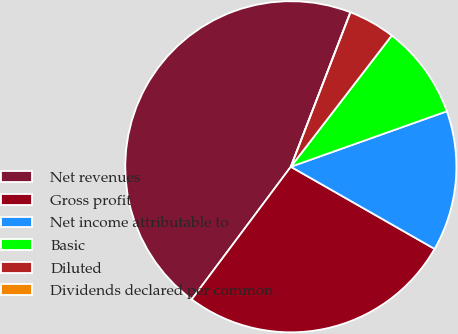Convert chart to OTSL. <chart><loc_0><loc_0><loc_500><loc_500><pie_chart><fcel>Net revenues<fcel>Gross profit<fcel>Net income attributable to<fcel>Basic<fcel>Diluted<fcel>Dividends declared per common<nl><fcel>45.65%<fcel>26.95%<fcel>13.7%<fcel>9.13%<fcel>4.57%<fcel>0.0%<nl></chart> 